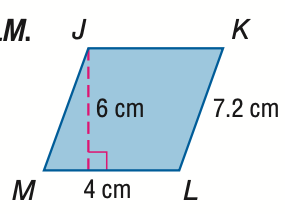Answer the mathemtical geometry problem and directly provide the correct option letter.
Question: Find the perimeter of \parallelogram J K L M.
Choices: A: 11.2 B: 22.4 C: 24 D: 44.8 B 